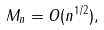Convert formula to latex. <formula><loc_0><loc_0><loc_500><loc_500>M _ { n } = O ( n ^ { 1 / 2 } ) ,</formula> 